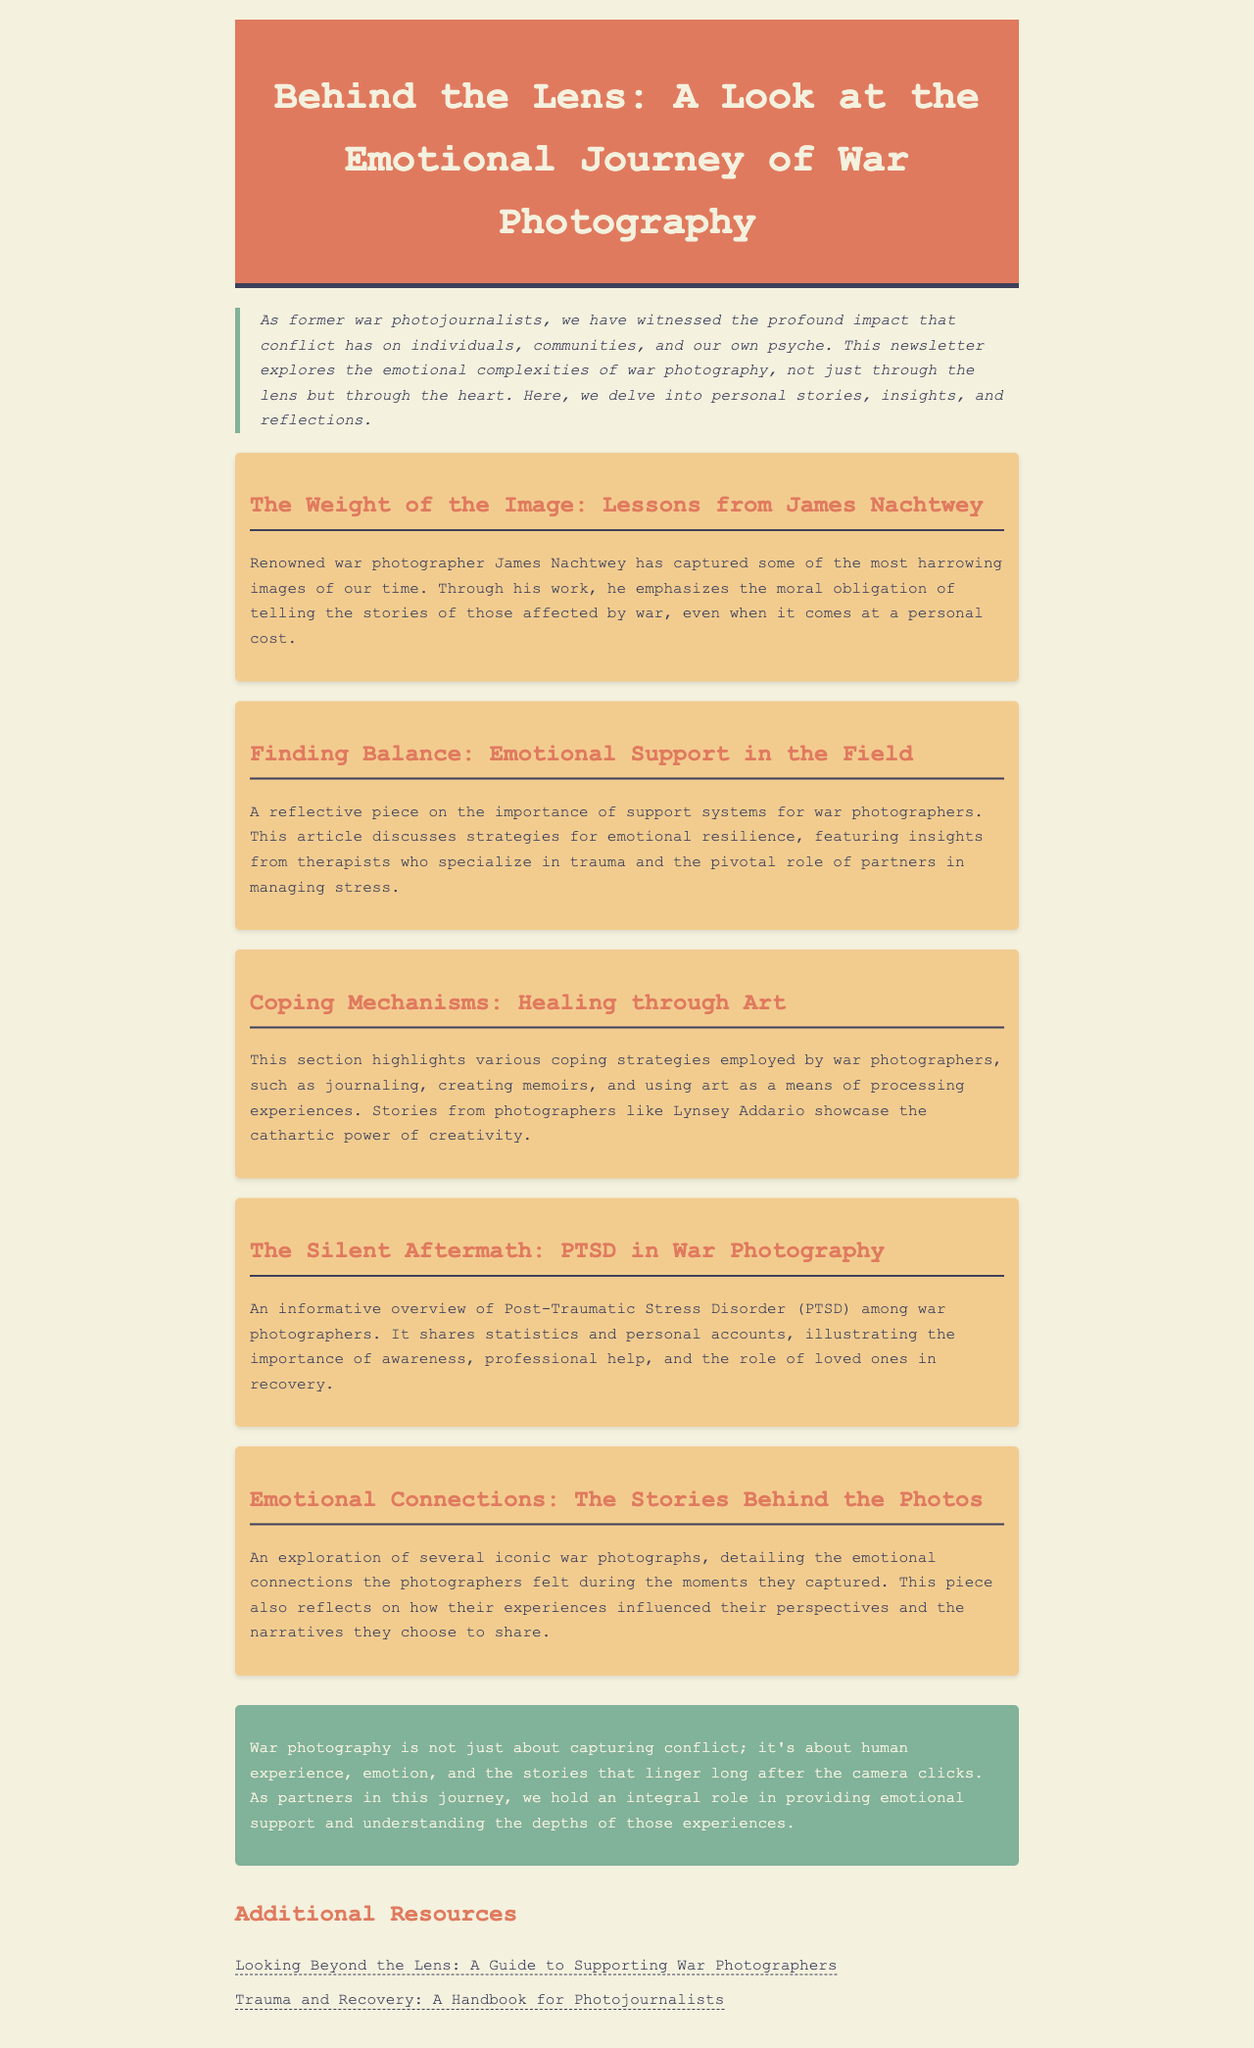what is the title of the newsletter? The title of the newsletter is prominently displayed at the top of the document.
Answer: Behind the Lens: A Look at the Emotional Journey of War Photography who is a renowned war photographer mentioned in the newsletter? The newsletter references a famous figure in war photography, emphasizing his impact.
Answer: James Nachtwey what topic does the second article discuss? The second article in the newsletter is about the emotional aspects of support for war photographers.
Answer: Emotional Support in the Field how does the newsletter describe the importance of partners? The newsletter highlights the crucial role of partners in providing emotional support and understanding.
Answer: Managing stress what is one coping mechanism discussed in the newsletter? The newsletter lists strategies that war photographers utilize to cope with their experiences.
Answer: Journaling how many additional resources are provided at the end of the newsletter? The newsletter concludes with a section that lists various resources available for war photographers.
Answer: Two what does the conclusion emphasize about war photography? The conclusion reflects on the broader impact of war photography beyond mere image capturing.
Answer: Human experience what emotional issue is highlighted in the article titled "The Silent Aftermath"? This article provides insight into a significant emotional challenge faced by war photographers.
Answer: PTSD 